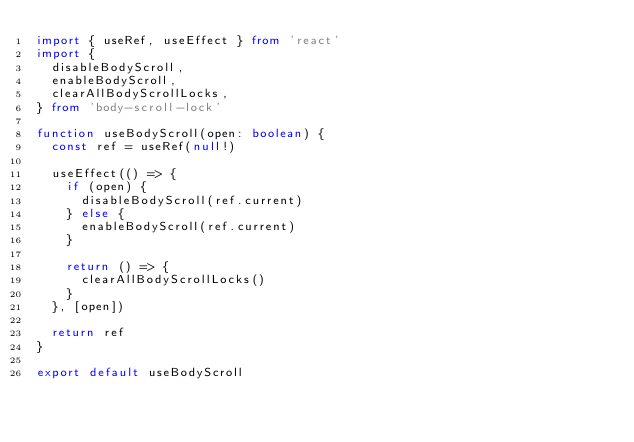<code> <loc_0><loc_0><loc_500><loc_500><_TypeScript_>import { useRef, useEffect } from 'react'
import {
  disableBodyScroll,
  enableBodyScroll,
  clearAllBodyScrollLocks,
} from 'body-scroll-lock'

function useBodyScroll(open: boolean) {
  const ref = useRef(null!)

  useEffect(() => {
    if (open) {
      disableBodyScroll(ref.current)
    } else {
      enableBodyScroll(ref.current)
    }

    return () => {
      clearAllBodyScrollLocks()
    }
  }, [open])

  return ref
}

export default useBodyScroll
</code> 